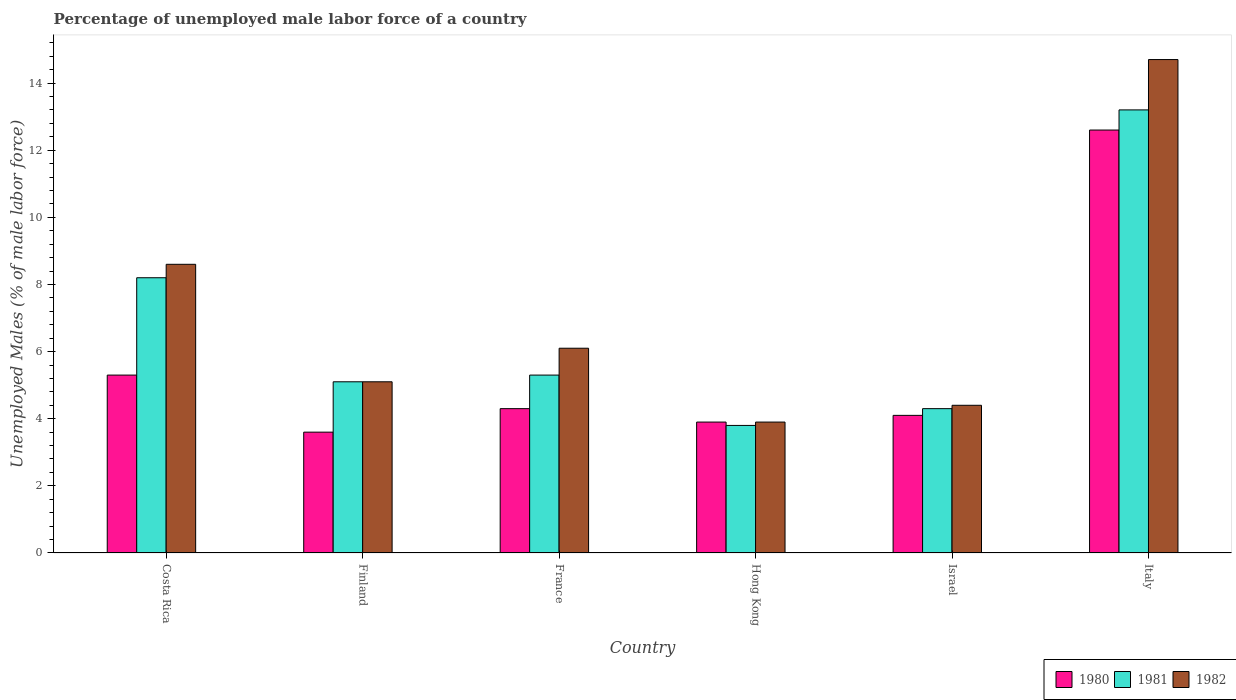Are the number of bars per tick equal to the number of legend labels?
Provide a short and direct response. Yes. What is the label of the 2nd group of bars from the left?
Offer a very short reply. Finland. In how many cases, is the number of bars for a given country not equal to the number of legend labels?
Your response must be concise. 0. What is the percentage of unemployed male labor force in 1981 in Israel?
Provide a short and direct response. 4.3. Across all countries, what is the maximum percentage of unemployed male labor force in 1980?
Provide a succinct answer. 12.6. Across all countries, what is the minimum percentage of unemployed male labor force in 1982?
Offer a terse response. 3.9. In which country was the percentage of unemployed male labor force in 1982 minimum?
Your answer should be compact. Hong Kong. What is the total percentage of unemployed male labor force in 1981 in the graph?
Give a very brief answer. 39.9. What is the difference between the percentage of unemployed male labor force in 1980 in Costa Rica and that in Finland?
Provide a succinct answer. 1.7. What is the difference between the percentage of unemployed male labor force in 1982 in Costa Rica and the percentage of unemployed male labor force in 1981 in Finland?
Your response must be concise. 3.5. What is the average percentage of unemployed male labor force in 1981 per country?
Give a very brief answer. 6.65. What is the difference between the percentage of unemployed male labor force of/in 1982 and percentage of unemployed male labor force of/in 1980 in France?
Provide a short and direct response. 1.8. In how many countries, is the percentage of unemployed male labor force in 1980 greater than 2 %?
Your answer should be compact. 6. What is the ratio of the percentage of unemployed male labor force in 1982 in Costa Rica to that in Finland?
Provide a succinct answer. 1.69. Is the percentage of unemployed male labor force in 1981 in Costa Rica less than that in Finland?
Ensure brevity in your answer.  No. What is the difference between the highest and the second highest percentage of unemployed male labor force in 1981?
Your response must be concise. 2.9. What is the difference between the highest and the lowest percentage of unemployed male labor force in 1981?
Offer a terse response. 9.4. What does the 3rd bar from the right in Israel represents?
Offer a terse response. 1980. How many bars are there?
Provide a succinct answer. 18. Are all the bars in the graph horizontal?
Your response must be concise. No. What is the difference between two consecutive major ticks on the Y-axis?
Offer a terse response. 2. Does the graph contain any zero values?
Keep it short and to the point. No. Does the graph contain grids?
Keep it short and to the point. No. How many legend labels are there?
Your response must be concise. 3. What is the title of the graph?
Offer a very short reply. Percentage of unemployed male labor force of a country. Does "1972" appear as one of the legend labels in the graph?
Provide a short and direct response. No. What is the label or title of the X-axis?
Your response must be concise. Country. What is the label or title of the Y-axis?
Make the answer very short. Unemployed Males (% of male labor force). What is the Unemployed Males (% of male labor force) of 1980 in Costa Rica?
Your response must be concise. 5.3. What is the Unemployed Males (% of male labor force) in 1981 in Costa Rica?
Provide a succinct answer. 8.2. What is the Unemployed Males (% of male labor force) in 1982 in Costa Rica?
Make the answer very short. 8.6. What is the Unemployed Males (% of male labor force) of 1980 in Finland?
Give a very brief answer. 3.6. What is the Unemployed Males (% of male labor force) in 1981 in Finland?
Your response must be concise. 5.1. What is the Unemployed Males (% of male labor force) in 1982 in Finland?
Offer a very short reply. 5.1. What is the Unemployed Males (% of male labor force) in 1980 in France?
Your answer should be compact. 4.3. What is the Unemployed Males (% of male labor force) in 1981 in France?
Make the answer very short. 5.3. What is the Unemployed Males (% of male labor force) in 1982 in France?
Give a very brief answer. 6.1. What is the Unemployed Males (% of male labor force) of 1980 in Hong Kong?
Provide a succinct answer. 3.9. What is the Unemployed Males (% of male labor force) in 1981 in Hong Kong?
Offer a terse response. 3.8. What is the Unemployed Males (% of male labor force) in 1982 in Hong Kong?
Provide a short and direct response. 3.9. What is the Unemployed Males (% of male labor force) in 1980 in Israel?
Your response must be concise. 4.1. What is the Unemployed Males (% of male labor force) in 1981 in Israel?
Make the answer very short. 4.3. What is the Unemployed Males (% of male labor force) of 1982 in Israel?
Provide a short and direct response. 4.4. What is the Unemployed Males (% of male labor force) in 1980 in Italy?
Offer a terse response. 12.6. What is the Unemployed Males (% of male labor force) of 1981 in Italy?
Provide a short and direct response. 13.2. What is the Unemployed Males (% of male labor force) of 1982 in Italy?
Provide a short and direct response. 14.7. Across all countries, what is the maximum Unemployed Males (% of male labor force) of 1980?
Provide a succinct answer. 12.6. Across all countries, what is the maximum Unemployed Males (% of male labor force) of 1981?
Provide a succinct answer. 13.2. Across all countries, what is the maximum Unemployed Males (% of male labor force) in 1982?
Provide a short and direct response. 14.7. Across all countries, what is the minimum Unemployed Males (% of male labor force) in 1980?
Your response must be concise. 3.6. Across all countries, what is the minimum Unemployed Males (% of male labor force) of 1981?
Your answer should be very brief. 3.8. Across all countries, what is the minimum Unemployed Males (% of male labor force) in 1982?
Make the answer very short. 3.9. What is the total Unemployed Males (% of male labor force) of 1980 in the graph?
Your response must be concise. 33.8. What is the total Unemployed Males (% of male labor force) in 1981 in the graph?
Your answer should be compact. 39.9. What is the total Unemployed Males (% of male labor force) of 1982 in the graph?
Give a very brief answer. 42.8. What is the difference between the Unemployed Males (% of male labor force) in 1980 in Costa Rica and that in Finland?
Provide a short and direct response. 1.7. What is the difference between the Unemployed Males (% of male labor force) in 1981 in Costa Rica and that in Finland?
Your answer should be very brief. 3.1. What is the difference between the Unemployed Males (% of male labor force) in 1982 in Costa Rica and that in Finland?
Keep it short and to the point. 3.5. What is the difference between the Unemployed Males (% of male labor force) in 1980 in Costa Rica and that in France?
Your answer should be compact. 1. What is the difference between the Unemployed Males (% of male labor force) in 1981 in Costa Rica and that in France?
Offer a terse response. 2.9. What is the difference between the Unemployed Males (% of male labor force) in 1980 in Costa Rica and that in Hong Kong?
Offer a terse response. 1.4. What is the difference between the Unemployed Males (% of male labor force) of 1982 in Costa Rica and that in Hong Kong?
Give a very brief answer. 4.7. What is the difference between the Unemployed Males (% of male labor force) in 1980 in Costa Rica and that in Israel?
Your answer should be very brief. 1.2. What is the difference between the Unemployed Males (% of male labor force) in 1981 in Costa Rica and that in Israel?
Offer a terse response. 3.9. What is the difference between the Unemployed Males (% of male labor force) of 1982 in Costa Rica and that in Israel?
Provide a succinct answer. 4.2. What is the difference between the Unemployed Males (% of male labor force) of 1980 in Costa Rica and that in Italy?
Ensure brevity in your answer.  -7.3. What is the difference between the Unemployed Males (% of male labor force) of 1981 in Costa Rica and that in Italy?
Provide a succinct answer. -5. What is the difference between the Unemployed Males (% of male labor force) in 1982 in Costa Rica and that in Italy?
Offer a very short reply. -6.1. What is the difference between the Unemployed Males (% of male labor force) of 1980 in Finland and that in France?
Your answer should be compact. -0.7. What is the difference between the Unemployed Males (% of male labor force) in 1981 in Finland and that in France?
Ensure brevity in your answer.  -0.2. What is the difference between the Unemployed Males (% of male labor force) in 1980 in Finland and that in Hong Kong?
Provide a succinct answer. -0.3. What is the difference between the Unemployed Males (% of male labor force) in 1981 in Finland and that in Hong Kong?
Offer a very short reply. 1.3. What is the difference between the Unemployed Males (% of male labor force) in 1982 in Finland and that in Hong Kong?
Offer a terse response. 1.2. What is the difference between the Unemployed Males (% of male labor force) in 1982 in Finland and that in Israel?
Keep it short and to the point. 0.7. What is the difference between the Unemployed Males (% of male labor force) in 1981 in Finland and that in Italy?
Your response must be concise. -8.1. What is the difference between the Unemployed Males (% of male labor force) of 1982 in Finland and that in Italy?
Offer a very short reply. -9.6. What is the difference between the Unemployed Males (% of male labor force) in 1980 in France and that in Hong Kong?
Offer a very short reply. 0.4. What is the difference between the Unemployed Males (% of male labor force) in 1981 in France and that in Hong Kong?
Provide a short and direct response. 1.5. What is the difference between the Unemployed Males (% of male labor force) in 1981 in France and that in Israel?
Offer a very short reply. 1. What is the difference between the Unemployed Males (% of male labor force) of 1982 in France and that in Israel?
Your answer should be very brief. 1.7. What is the difference between the Unemployed Males (% of male labor force) in 1981 in France and that in Italy?
Your answer should be compact. -7.9. What is the difference between the Unemployed Males (% of male labor force) of 1982 in France and that in Italy?
Your answer should be very brief. -8.6. What is the difference between the Unemployed Males (% of male labor force) of 1981 in Hong Kong and that in Israel?
Your answer should be compact. -0.5. What is the difference between the Unemployed Males (% of male labor force) of 1982 in Hong Kong and that in Israel?
Ensure brevity in your answer.  -0.5. What is the difference between the Unemployed Males (% of male labor force) of 1980 in Hong Kong and that in Italy?
Offer a terse response. -8.7. What is the difference between the Unemployed Males (% of male labor force) of 1980 in Israel and that in Italy?
Your answer should be compact. -8.5. What is the difference between the Unemployed Males (% of male labor force) of 1982 in Israel and that in Italy?
Your answer should be compact. -10.3. What is the difference between the Unemployed Males (% of male labor force) of 1980 in Costa Rica and the Unemployed Males (% of male labor force) of 1982 in Finland?
Offer a terse response. 0.2. What is the difference between the Unemployed Males (% of male labor force) in 1981 in Costa Rica and the Unemployed Males (% of male labor force) in 1982 in Finland?
Keep it short and to the point. 3.1. What is the difference between the Unemployed Males (% of male labor force) of 1980 in Costa Rica and the Unemployed Males (% of male labor force) of 1981 in France?
Your answer should be very brief. 0. What is the difference between the Unemployed Males (% of male labor force) of 1980 in Costa Rica and the Unemployed Males (% of male labor force) of 1982 in France?
Your response must be concise. -0.8. What is the difference between the Unemployed Males (% of male labor force) of 1981 in Costa Rica and the Unemployed Males (% of male labor force) of 1982 in France?
Provide a succinct answer. 2.1. What is the difference between the Unemployed Males (% of male labor force) in 1980 in Costa Rica and the Unemployed Males (% of male labor force) in 1981 in Hong Kong?
Offer a very short reply. 1.5. What is the difference between the Unemployed Males (% of male labor force) in 1981 in Costa Rica and the Unemployed Males (% of male labor force) in 1982 in Hong Kong?
Provide a short and direct response. 4.3. What is the difference between the Unemployed Males (% of male labor force) of 1980 in Costa Rica and the Unemployed Males (% of male labor force) of 1981 in Israel?
Your answer should be compact. 1. What is the difference between the Unemployed Males (% of male labor force) of 1981 in Finland and the Unemployed Males (% of male labor force) of 1982 in France?
Ensure brevity in your answer.  -1. What is the difference between the Unemployed Males (% of male labor force) of 1980 in Finland and the Unemployed Males (% of male labor force) of 1981 in Hong Kong?
Your response must be concise. -0.2. What is the difference between the Unemployed Males (% of male labor force) of 1980 in Finland and the Unemployed Males (% of male labor force) of 1982 in Hong Kong?
Keep it short and to the point. -0.3. What is the difference between the Unemployed Males (% of male labor force) of 1981 in Finland and the Unemployed Males (% of male labor force) of 1982 in Israel?
Your answer should be very brief. 0.7. What is the difference between the Unemployed Males (% of male labor force) of 1980 in Finland and the Unemployed Males (% of male labor force) of 1981 in Italy?
Keep it short and to the point. -9.6. What is the difference between the Unemployed Males (% of male labor force) of 1981 in Finland and the Unemployed Males (% of male labor force) of 1982 in Italy?
Make the answer very short. -9.6. What is the difference between the Unemployed Males (% of male labor force) of 1980 in France and the Unemployed Males (% of male labor force) of 1982 in Hong Kong?
Ensure brevity in your answer.  0.4. What is the difference between the Unemployed Males (% of male labor force) in 1981 in France and the Unemployed Males (% of male labor force) in 1982 in Hong Kong?
Ensure brevity in your answer.  1.4. What is the difference between the Unemployed Males (% of male labor force) of 1980 in France and the Unemployed Males (% of male labor force) of 1981 in Israel?
Ensure brevity in your answer.  0. What is the difference between the Unemployed Males (% of male labor force) of 1980 in France and the Unemployed Males (% of male labor force) of 1982 in Israel?
Give a very brief answer. -0.1. What is the difference between the Unemployed Males (% of male labor force) of 1980 in France and the Unemployed Males (% of male labor force) of 1981 in Italy?
Provide a succinct answer. -8.9. What is the difference between the Unemployed Males (% of male labor force) in 1981 in France and the Unemployed Males (% of male labor force) in 1982 in Italy?
Give a very brief answer. -9.4. What is the difference between the Unemployed Males (% of male labor force) of 1980 in Hong Kong and the Unemployed Males (% of male labor force) of 1981 in Israel?
Offer a very short reply. -0.4. What is the difference between the Unemployed Males (% of male labor force) in 1980 in Israel and the Unemployed Males (% of male labor force) in 1982 in Italy?
Provide a succinct answer. -10.6. What is the average Unemployed Males (% of male labor force) of 1980 per country?
Your response must be concise. 5.63. What is the average Unemployed Males (% of male labor force) in 1981 per country?
Give a very brief answer. 6.65. What is the average Unemployed Males (% of male labor force) of 1982 per country?
Your response must be concise. 7.13. What is the difference between the Unemployed Males (% of male labor force) of 1980 and Unemployed Males (% of male labor force) of 1981 in Finland?
Offer a terse response. -1.5. What is the difference between the Unemployed Males (% of male labor force) in 1981 and Unemployed Males (% of male labor force) in 1982 in Finland?
Make the answer very short. 0. What is the difference between the Unemployed Males (% of male labor force) in 1980 and Unemployed Males (% of male labor force) in 1981 in France?
Your answer should be compact. -1. What is the difference between the Unemployed Males (% of male labor force) in 1981 and Unemployed Males (% of male labor force) in 1982 in France?
Your answer should be compact. -0.8. What is the difference between the Unemployed Males (% of male labor force) of 1980 and Unemployed Males (% of male labor force) of 1982 in Hong Kong?
Make the answer very short. 0. What is the difference between the Unemployed Males (% of male labor force) in 1981 and Unemployed Males (% of male labor force) in 1982 in Hong Kong?
Your answer should be compact. -0.1. What is the ratio of the Unemployed Males (% of male labor force) of 1980 in Costa Rica to that in Finland?
Keep it short and to the point. 1.47. What is the ratio of the Unemployed Males (% of male labor force) of 1981 in Costa Rica to that in Finland?
Provide a short and direct response. 1.61. What is the ratio of the Unemployed Males (% of male labor force) of 1982 in Costa Rica to that in Finland?
Your response must be concise. 1.69. What is the ratio of the Unemployed Males (% of male labor force) of 1980 in Costa Rica to that in France?
Offer a terse response. 1.23. What is the ratio of the Unemployed Males (% of male labor force) of 1981 in Costa Rica to that in France?
Your answer should be compact. 1.55. What is the ratio of the Unemployed Males (% of male labor force) in 1982 in Costa Rica to that in France?
Ensure brevity in your answer.  1.41. What is the ratio of the Unemployed Males (% of male labor force) of 1980 in Costa Rica to that in Hong Kong?
Ensure brevity in your answer.  1.36. What is the ratio of the Unemployed Males (% of male labor force) in 1981 in Costa Rica to that in Hong Kong?
Your response must be concise. 2.16. What is the ratio of the Unemployed Males (% of male labor force) in 1982 in Costa Rica to that in Hong Kong?
Ensure brevity in your answer.  2.21. What is the ratio of the Unemployed Males (% of male labor force) in 1980 in Costa Rica to that in Israel?
Give a very brief answer. 1.29. What is the ratio of the Unemployed Males (% of male labor force) of 1981 in Costa Rica to that in Israel?
Provide a succinct answer. 1.91. What is the ratio of the Unemployed Males (% of male labor force) of 1982 in Costa Rica to that in Israel?
Offer a terse response. 1.95. What is the ratio of the Unemployed Males (% of male labor force) in 1980 in Costa Rica to that in Italy?
Keep it short and to the point. 0.42. What is the ratio of the Unemployed Males (% of male labor force) in 1981 in Costa Rica to that in Italy?
Offer a very short reply. 0.62. What is the ratio of the Unemployed Males (% of male labor force) in 1982 in Costa Rica to that in Italy?
Provide a short and direct response. 0.58. What is the ratio of the Unemployed Males (% of male labor force) of 1980 in Finland to that in France?
Provide a short and direct response. 0.84. What is the ratio of the Unemployed Males (% of male labor force) in 1981 in Finland to that in France?
Keep it short and to the point. 0.96. What is the ratio of the Unemployed Males (% of male labor force) in 1982 in Finland to that in France?
Provide a succinct answer. 0.84. What is the ratio of the Unemployed Males (% of male labor force) of 1980 in Finland to that in Hong Kong?
Your answer should be very brief. 0.92. What is the ratio of the Unemployed Males (% of male labor force) in 1981 in Finland to that in Hong Kong?
Your response must be concise. 1.34. What is the ratio of the Unemployed Males (% of male labor force) of 1982 in Finland to that in Hong Kong?
Keep it short and to the point. 1.31. What is the ratio of the Unemployed Males (% of male labor force) of 1980 in Finland to that in Israel?
Offer a very short reply. 0.88. What is the ratio of the Unemployed Males (% of male labor force) of 1981 in Finland to that in Israel?
Ensure brevity in your answer.  1.19. What is the ratio of the Unemployed Males (% of male labor force) of 1982 in Finland to that in Israel?
Provide a succinct answer. 1.16. What is the ratio of the Unemployed Males (% of male labor force) of 1980 in Finland to that in Italy?
Provide a succinct answer. 0.29. What is the ratio of the Unemployed Males (% of male labor force) of 1981 in Finland to that in Italy?
Offer a terse response. 0.39. What is the ratio of the Unemployed Males (% of male labor force) of 1982 in Finland to that in Italy?
Your response must be concise. 0.35. What is the ratio of the Unemployed Males (% of male labor force) in 1980 in France to that in Hong Kong?
Your answer should be very brief. 1.1. What is the ratio of the Unemployed Males (% of male labor force) in 1981 in France to that in Hong Kong?
Provide a short and direct response. 1.39. What is the ratio of the Unemployed Males (% of male labor force) of 1982 in France to that in Hong Kong?
Provide a succinct answer. 1.56. What is the ratio of the Unemployed Males (% of male labor force) in 1980 in France to that in Israel?
Make the answer very short. 1.05. What is the ratio of the Unemployed Males (% of male labor force) in 1981 in France to that in Israel?
Ensure brevity in your answer.  1.23. What is the ratio of the Unemployed Males (% of male labor force) in 1982 in France to that in Israel?
Give a very brief answer. 1.39. What is the ratio of the Unemployed Males (% of male labor force) of 1980 in France to that in Italy?
Provide a short and direct response. 0.34. What is the ratio of the Unemployed Males (% of male labor force) of 1981 in France to that in Italy?
Make the answer very short. 0.4. What is the ratio of the Unemployed Males (% of male labor force) of 1982 in France to that in Italy?
Give a very brief answer. 0.41. What is the ratio of the Unemployed Males (% of male labor force) of 1980 in Hong Kong to that in Israel?
Make the answer very short. 0.95. What is the ratio of the Unemployed Males (% of male labor force) in 1981 in Hong Kong to that in Israel?
Offer a terse response. 0.88. What is the ratio of the Unemployed Males (% of male labor force) in 1982 in Hong Kong to that in Israel?
Give a very brief answer. 0.89. What is the ratio of the Unemployed Males (% of male labor force) of 1980 in Hong Kong to that in Italy?
Offer a very short reply. 0.31. What is the ratio of the Unemployed Males (% of male labor force) of 1981 in Hong Kong to that in Italy?
Offer a very short reply. 0.29. What is the ratio of the Unemployed Males (% of male labor force) of 1982 in Hong Kong to that in Italy?
Provide a short and direct response. 0.27. What is the ratio of the Unemployed Males (% of male labor force) of 1980 in Israel to that in Italy?
Provide a succinct answer. 0.33. What is the ratio of the Unemployed Males (% of male labor force) of 1981 in Israel to that in Italy?
Your answer should be very brief. 0.33. What is the ratio of the Unemployed Males (% of male labor force) in 1982 in Israel to that in Italy?
Provide a succinct answer. 0.3. What is the difference between the highest and the second highest Unemployed Males (% of male labor force) in 1981?
Your answer should be compact. 5. What is the difference between the highest and the second highest Unemployed Males (% of male labor force) in 1982?
Your answer should be compact. 6.1. What is the difference between the highest and the lowest Unemployed Males (% of male labor force) of 1982?
Make the answer very short. 10.8. 